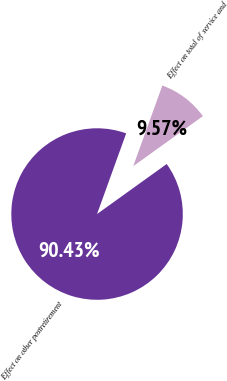Convert chart to OTSL. <chart><loc_0><loc_0><loc_500><loc_500><pie_chart><fcel>Effect on total of service and<fcel>Effect on other postretirement<nl><fcel>9.57%<fcel>90.43%<nl></chart> 